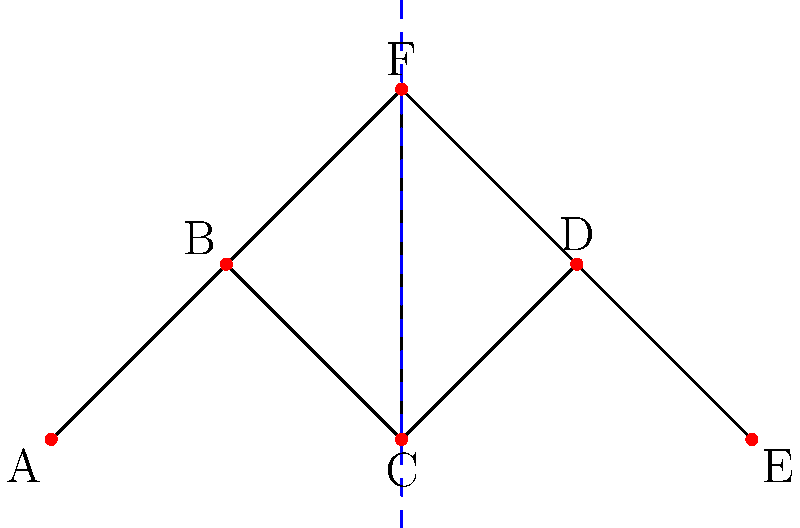In the context of graph partitioning for balanced layout creation in graphic design software, consider the graph shown above. What is the minimum number of edges that need to be cut to partition this graph into two parts with an equal number of vertices, and how many such optimal partitions exist? To solve this problem, we need to follow these steps:

1. Understand the goal: We want to divide the graph into two parts with an equal number of vertices (3 vertices each) while cutting the minimum number of edges.

2. Identify possible partitions:
   - There are $\binom{6}{3} = 20$ ways to choose 3 vertices out of 6.
   - However, due to symmetry, we only need to consider half of these.

3. Evaluate each partition:
   a) {A,B,C} | {D,E,F}: Cuts 3 edges
   b) {A,B,F} | {C,D,E}: Cuts 3 edges
   c) {A,C,E} | {B,D,F}: Cuts 4 edges
   d) {A,C,F} | {B,D,E}: Cuts 2 edges
   e) {A,D,E} | {B,C,F}: Cuts 3 edges

4. Identify the optimal solution:
   - The minimum number of edges to be cut is 2.
   - This occurs in the partition {A,C,F} | {B,D,E}.

5. Count optimal partitions:
   - There is only one optimal partition that cuts 2 edges.

Therefore, the minimum number of edges to be cut is 2, and there is 1 such optimal partition.
Answer: 2 edges; 1 optimal partition 